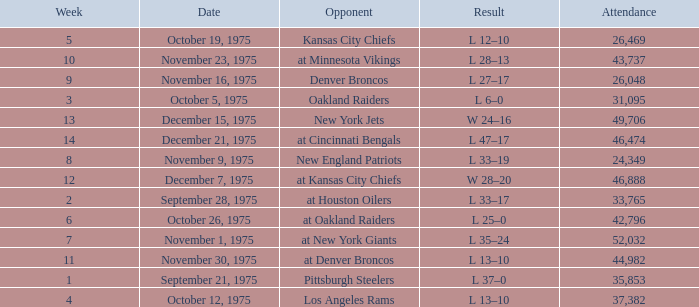What is the highest Week when the opponent was kansas city chiefs, with more than 26,469 in attendance? None. 